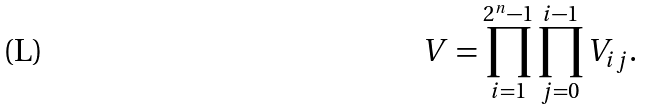<formula> <loc_0><loc_0><loc_500><loc_500>V = \prod ^ { 2 ^ { n } - 1 } _ { i = 1 } \prod ^ { i - 1 } _ { j = 0 } V _ { i j } .</formula> 